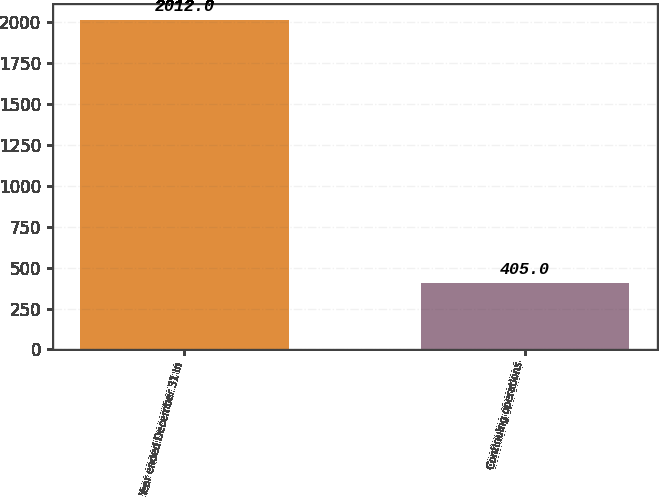Convert chart. <chart><loc_0><loc_0><loc_500><loc_500><bar_chart><fcel>Year ended December 31 In<fcel>Continuing operations<nl><fcel>2012<fcel>405<nl></chart> 